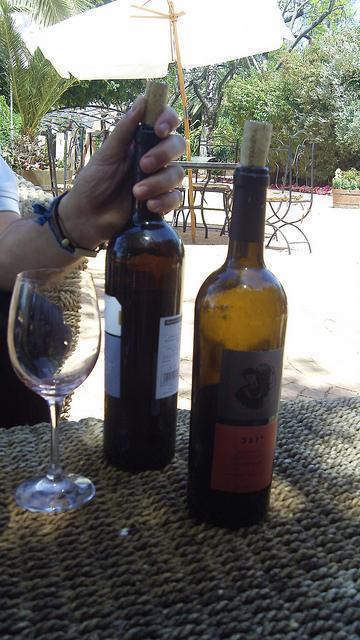How many bottles are there?
Give a very brief answer. 2. How many apples are there?
Give a very brief answer. 0. 